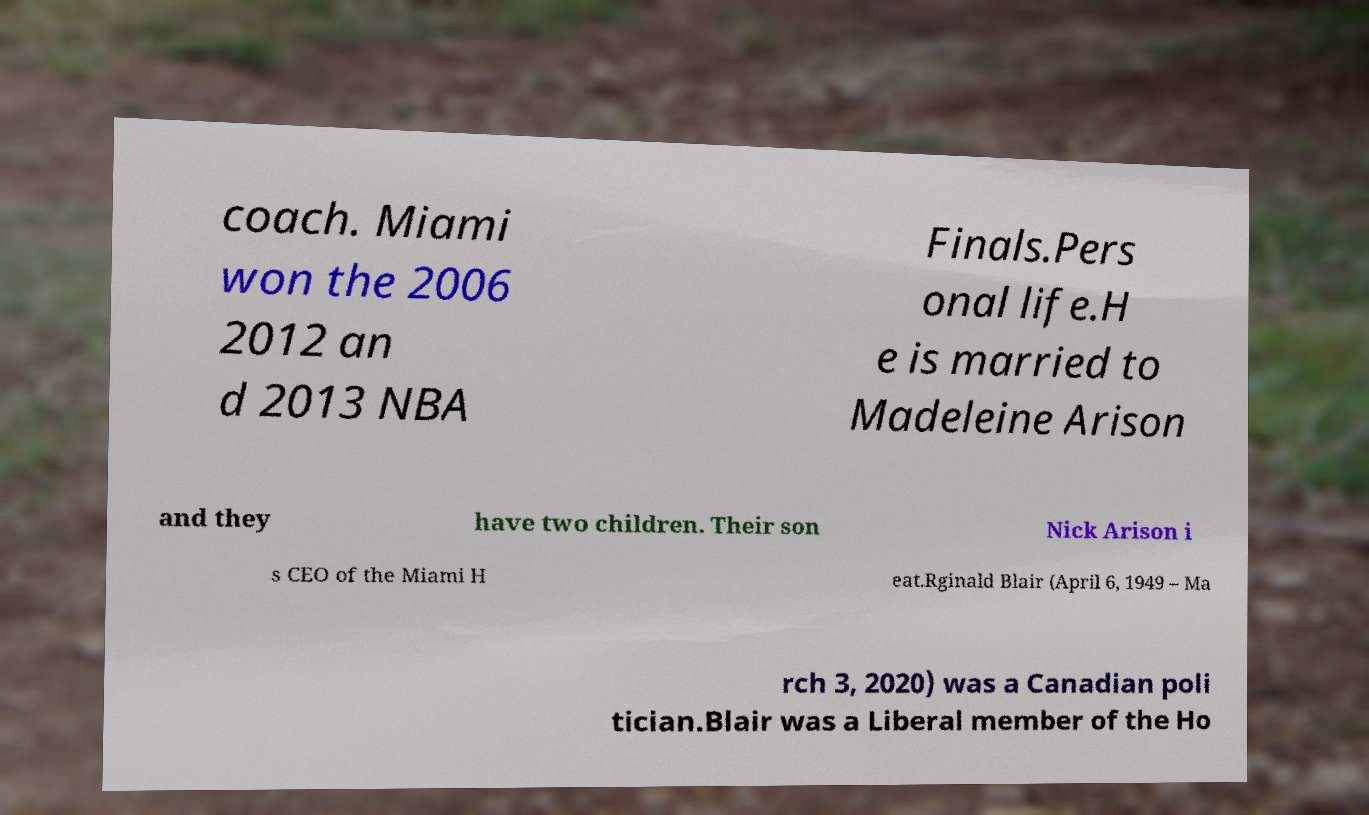Please read and relay the text visible in this image. What does it say? coach. Miami won the 2006 2012 an d 2013 NBA Finals.Pers onal life.H e is married to Madeleine Arison and they have two children. Their son Nick Arison i s CEO of the Miami H eat.Rginald Blair (April 6, 1949 – Ma rch 3, 2020) was a Canadian poli tician.Blair was a Liberal member of the Ho 